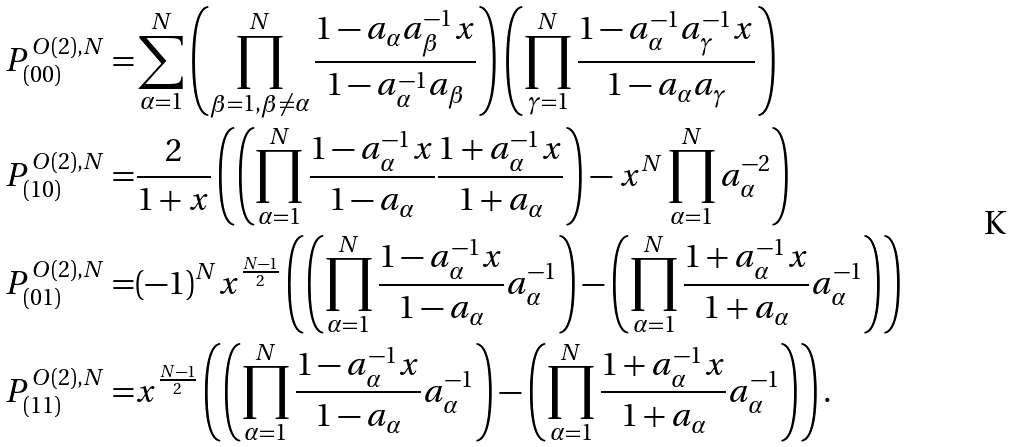<formula> <loc_0><loc_0><loc_500><loc_500>P ^ { O ( 2 ) , N } _ { ( 0 0 ) } = & \sum _ { \alpha = 1 } ^ { N } \left ( \prod _ { \beta = 1 , \beta \neq \alpha } ^ { N } \frac { 1 - a _ { \alpha } a _ { \beta } ^ { - 1 } x } { 1 - a _ { \alpha } ^ { - 1 } a _ { \beta } } \right ) \left ( \prod _ { \gamma = 1 } ^ { N } \frac { 1 - a _ { \alpha } ^ { - 1 } a _ { \gamma } ^ { - 1 } x } { 1 - a _ { \alpha } a _ { \gamma } } \right ) \\ P ^ { O ( 2 ) , N } _ { ( 1 0 ) } = & \frac { 2 } { 1 + x } \left ( \left ( \prod _ { \alpha = 1 } ^ { N } \frac { 1 - a _ { \alpha } ^ { - 1 } x } { 1 - a _ { \alpha } } \frac { 1 + a _ { \alpha } ^ { - 1 } x } { 1 + a _ { \alpha } } \right ) - x ^ { N } \prod _ { \alpha = 1 } ^ { N } a _ { \alpha } ^ { - 2 } \right ) \\ P ^ { O ( 2 ) , N } _ { ( 0 1 ) } = & ( - 1 ) ^ { N } x ^ { \frac { N - 1 } { 2 } } \left ( \left ( \prod _ { \alpha = 1 } ^ { N } \frac { 1 - a _ { \alpha } ^ { - 1 } x } { 1 - a _ { \alpha } } a _ { \alpha } ^ { - 1 } \right ) - \left ( \prod _ { \alpha = 1 } ^ { N } \frac { 1 + a _ { \alpha } ^ { - 1 } x } { 1 + a _ { \alpha } } a _ { \alpha } ^ { - 1 } \right ) \right ) \\ P ^ { O ( 2 ) , N } _ { ( 1 1 ) } = & x ^ { \frac { N - 1 } { 2 } } \left ( \left ( \prod _ { \alpha = 1 } ^ { N } \frac { 1 - a _ { \alpha } ^ { - 1 } x } { 1 - a _ { \alpha } } a _ { \alpha } ^ { - 1 } \right ) - \left ( \prod _ { \alpha = 1 } ^ { N } \frac { 1 + a _ { \alpha } ^ { - 1 } x } { 1 + a _ { \alpha } } a _ { \alpha } ^ { - 1 } \right ) \right ) .</formula> 